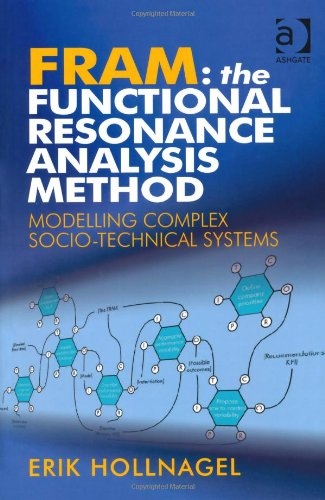Can you explain how FRAM can be applied in a real-world scenario? FRAM can be applied in numerous scenarios, such as healthcare, aviation, and nuclear power operations, where understanding interactions between various system components is crucial for enhancing safety and efficiency. It allows professionals to predict how different variables might interact under changing conditions, thus providing a robust method for improving systemic resilience and decision-making. 